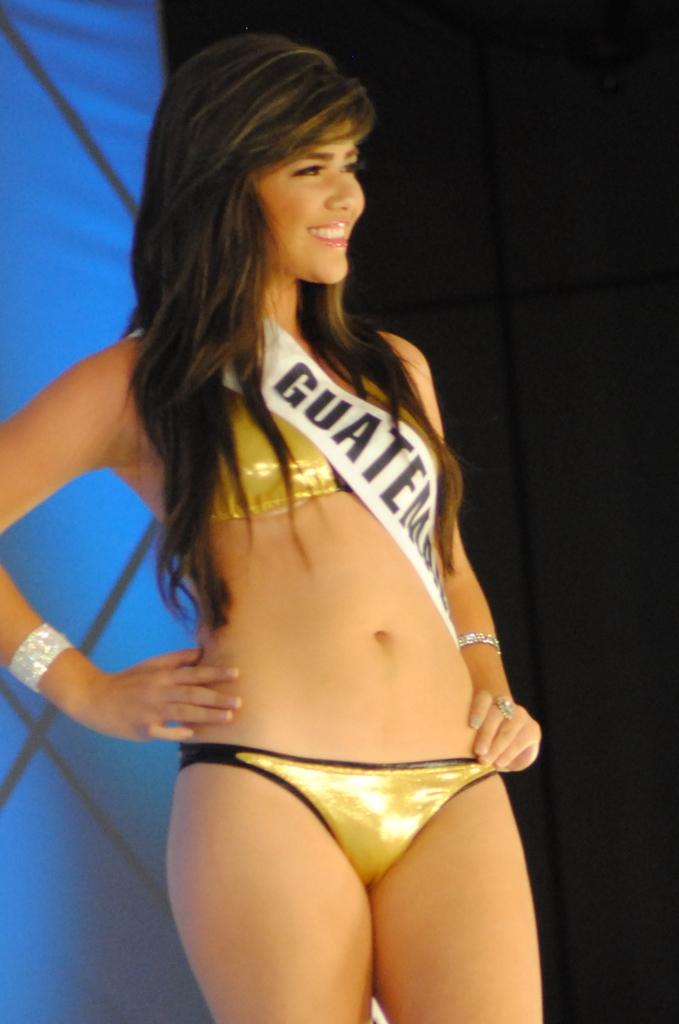What is the primary subject of the image? There is a woman in the image. What is the woman doing in the image? The woman is standing and smiling. What is the woman wearing in the image? The woman is wearing a bikini. Are there any other objects present in the image besides the woman? Yes, there are other objects present in the image. Can you see the woman twisting a feather in the image? No, there is no feather present in the image, and the woman is not performing any twisting action. 